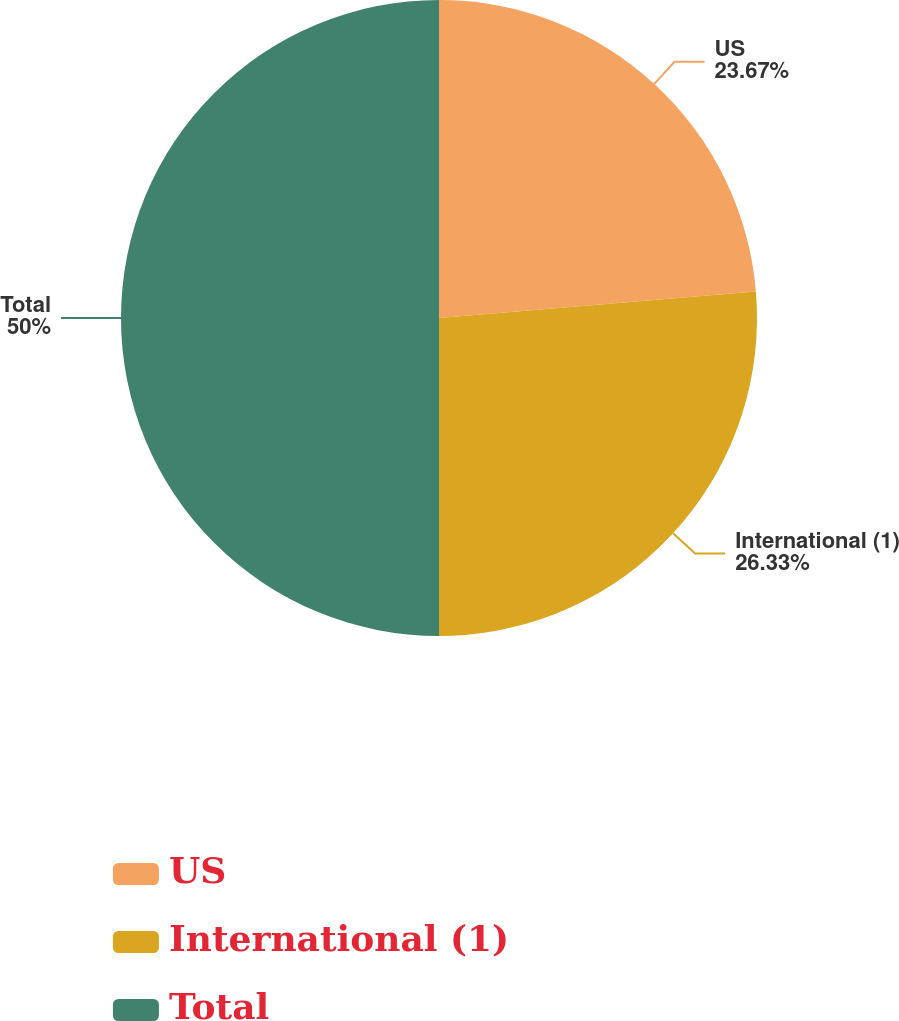<chart> <loc_0><loc_0><loc_500><loc_500><pie_chart><fcel>US<fcel>International (1)<fcel>Total<nl><fcel>23.67%<fcel>26.33%<fcel>50.0%<nl></chart> 